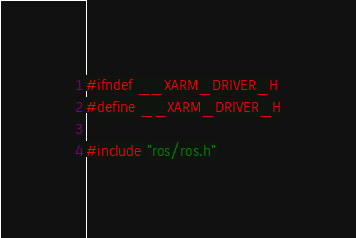Convert code to text. <code><loc_0><loc_0><loc_500><loc_500><_C_>#ifndef __XARM_DRIVER_H
#define __XARM_DRIVER_H

#include "ros/ros.h"</code> 